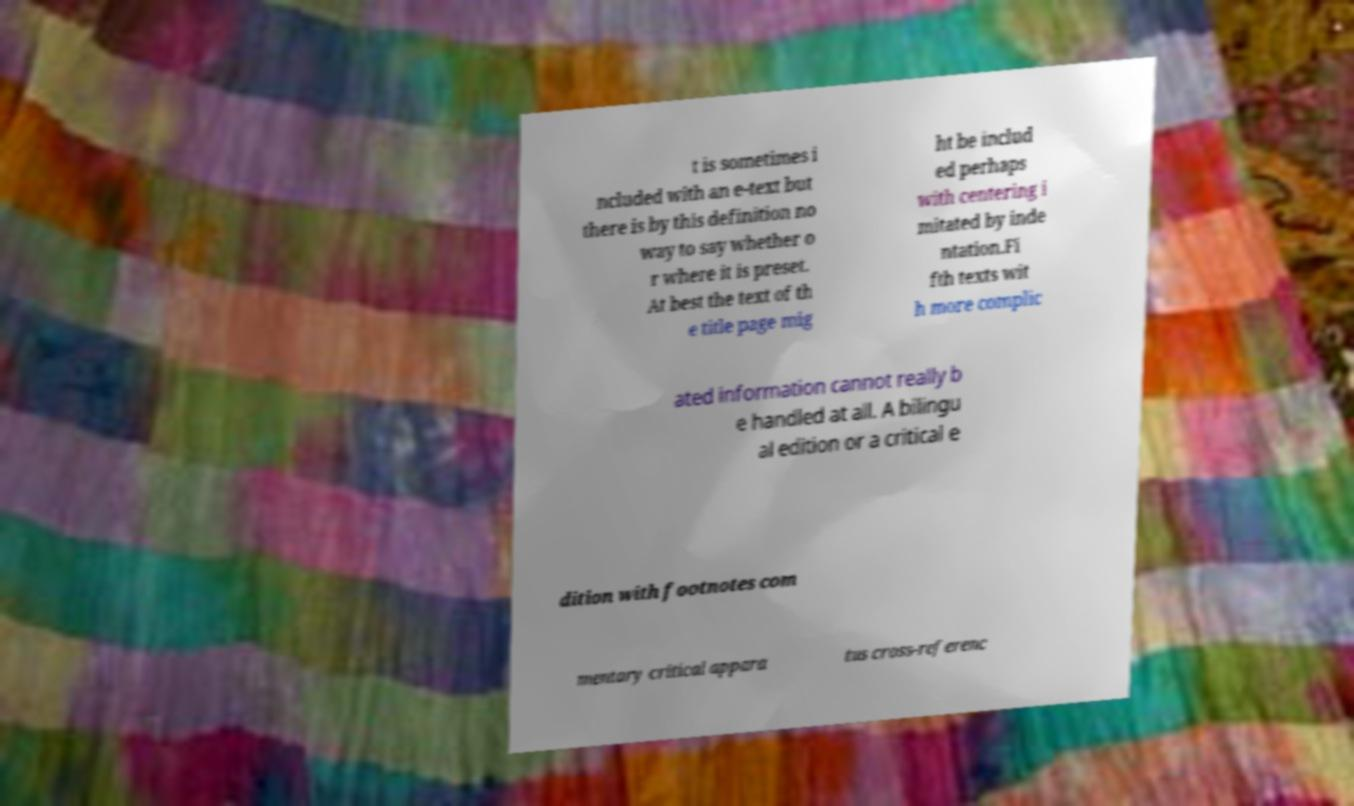Please identify and transcribe the text found in this image. t is sometimes i ncluded with an e-text but there is by this definition no way to say whether o r where it is preset. At best the text of th e title page mig ht be includ ed perhaps with centering i mitated by inde ntation.Fi fth texts wit h more complic ated information cannot really b e handled at all. A bilingu al edition or a critical e dition with footnotes com mentary critical appara tus cross-referenc 